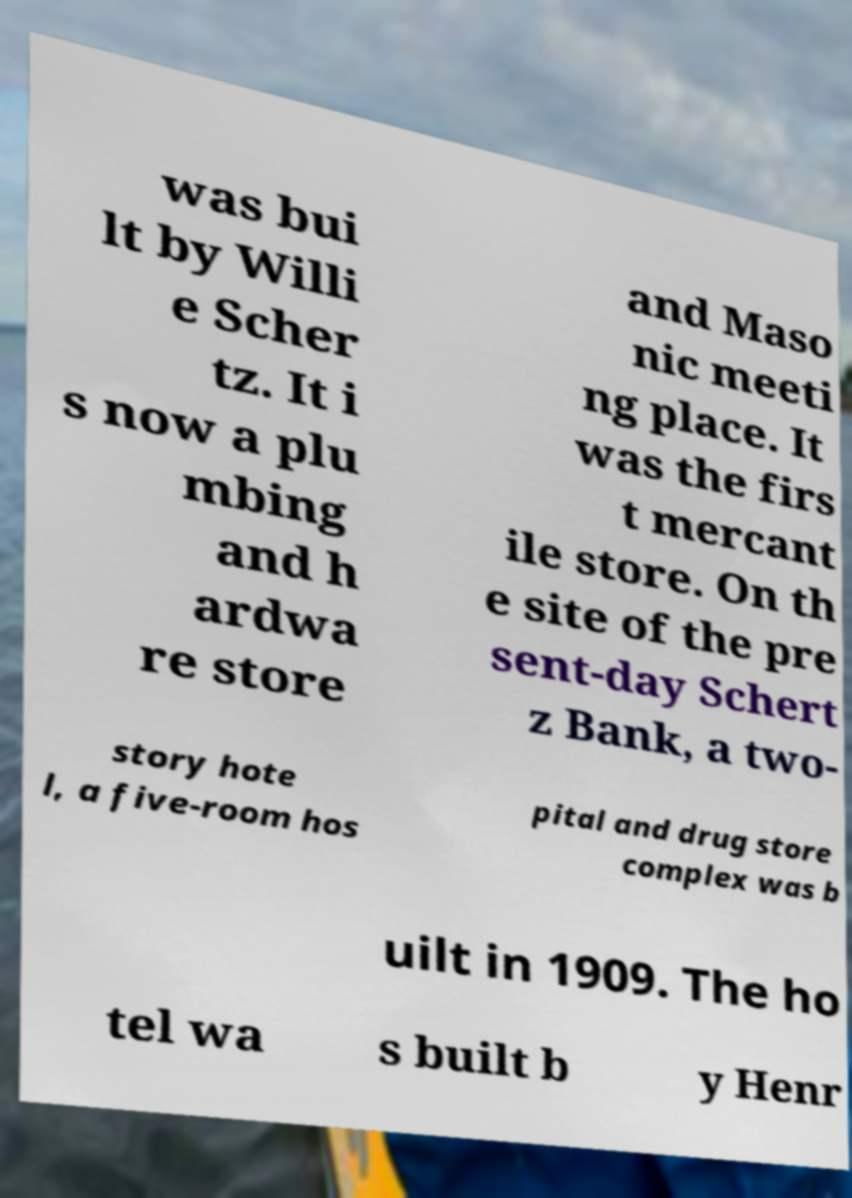What messages or text are displayed in this image? I need them in a readable, typed format. was bui lt by Willi e Scher tz. It i s now a plu mbing and h ardwa re store and Maso nic meeti ng place. It was the firs t mercant ile store. On th e site of the pre sent-day Schert z Bank, a two- story hote l, a five-room hos pital and drug store complex was b uilt in 1909. The ho tel wa s built b y Henr 